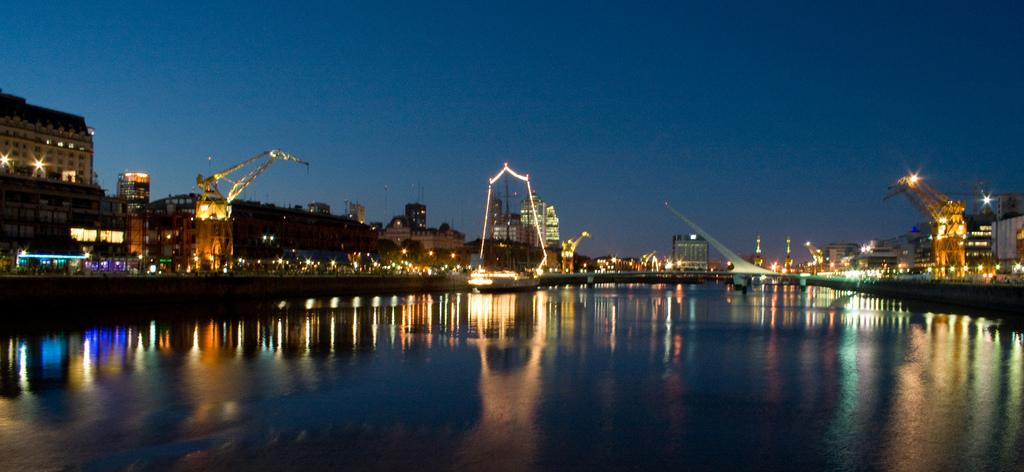What is visible in the image? Water is visible in the image. What can be seen in the background of the image? There are lights and buildings in the background of the image. What is the color of the sky in the image? The sky is blue in color. What type of idea is being discussed by the coach in the image? There is no coach or discussion present in the image; it only features water, lights, buildings, and a blue sky. 